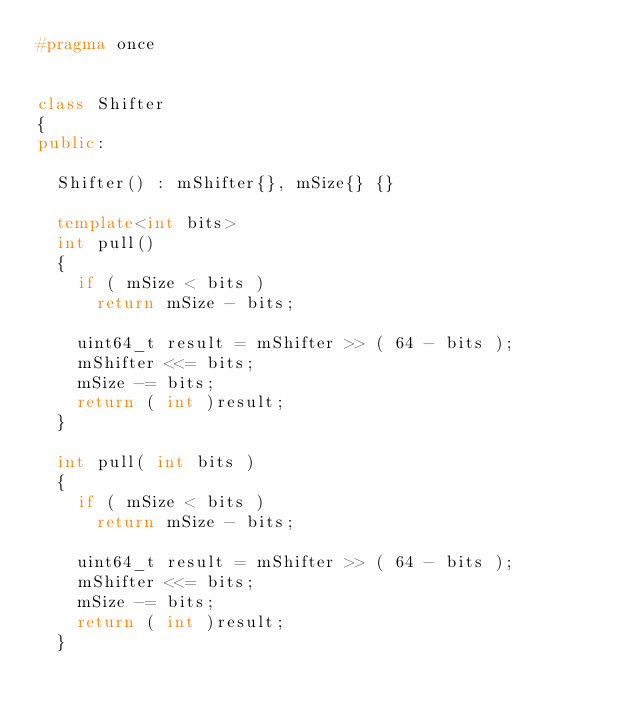Convert code to text. <code><loc_0><loc_0><loc_500><loc_500><_C++_>#pragma once


class Shifter
{
public:

  Shifter() : mShifter{}, mSize{} {}

  template<int bits>
  int pull()
  {
    if ( mSize < bits )
      return mSize - bits;

    uint64_t result = mShifter >> ( 64 - bits );
    mShifter <<= bits;
    mSize -= bits;
    return ( int )result;
  }

  int pull( int bits )
  {
    if ( mSize < bits )
      return mSize - bits;

    uint64_t result = mShifter >> ( 64 - bits );
    mShifter <<= bits;
    mSize -= bits;
    return ( int )result;
  }
</code> 